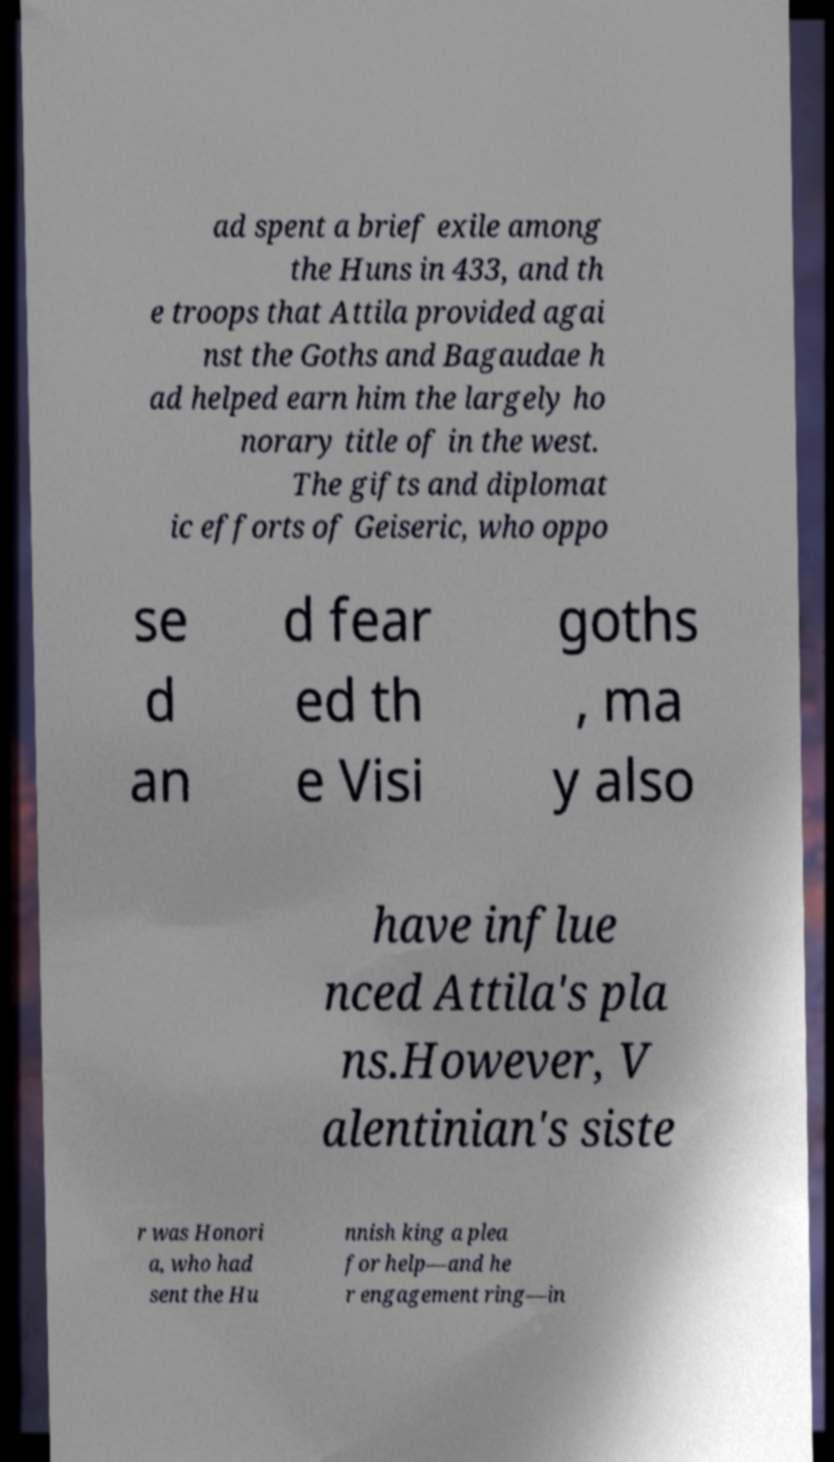Please identify and transcribe the text found in this image. ad spent a brief exile among the Huns in 433, and th e troops that Attila provided agai nst the Goths and Bagaudae h ad helped earn him the largely ho norary title of in the west. The gifts and diplomat ic efforts of Geiseric, who oppo se d an d fear ed th e Visi goths , ma y also have influe nced Attila's pla ns.However, V alentinian's siste r was Honori a, who had sent the Hu nnish king a plea for help—and he r engagement ring—in 